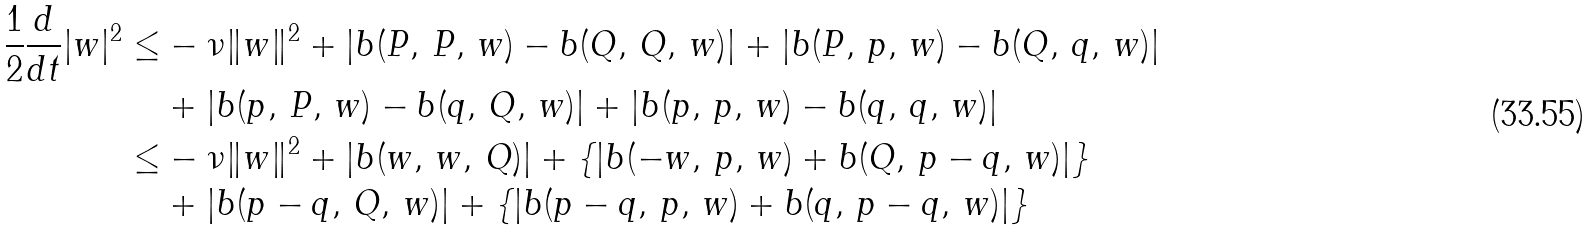<formula> <loc_0><loc_0><loc_500><loc_500>\frac { 1 } { 2 } \frac { d } { d t } | w | ^ { 2 } \leq & - \nu \| w \| ^ { 2 } + | b ( P , \, P , \, w ) - b ( Q , \, Q , \, w ) | + | b ( P , \, p , \, w ) - b ( Q , \, q , \, w ) | \\ & + | b ( p , \, P , \, w ) - b ( q , \, Q , \, w ) | + | b ( p , \, p , \, w ) - b ( q , \, q , \, w ) | \\ \leq & - \nu \| w \| ^ { 2 } + | b ( w , \, w , \, Q ) | + \left \{ | b ( - w , \, p , \, w ) + b ( Q , \, p - q , \, w ) | \right \} \\ & + | b ( p - q , \, Q , \, w ) | + \left \{ | b ( p - q , \, p , \, w ) + b ( q , \, p - q , \, w ) | \right \}</formula> 